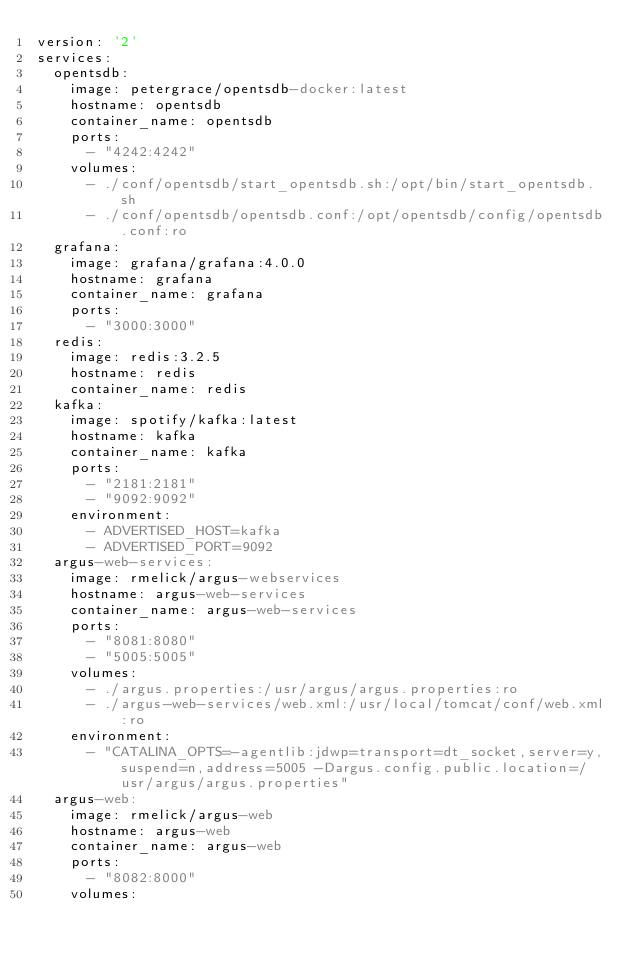<code> <loc_0><loc_0><loc_500><loc_500><_YAML_>version: '2'
services:
  opentsdb:
    image: petergrace/opentsdb-docker:latest
    hostname: opentsdb
    container_name: opentsdb
    ports:
      - "4242:4242"
    volumes:
      - ./conf/opentsdb/start_opentsdb.sh:/opt/bin/start_opentsdb.sh
      - ./conf/opentsdb/opentsdb.conf:/opt/opentsdb/config/opentsdb.conf:ro
  grafana:
    image: grafana/grafana:4.0.0
    hostname: grafana
    container_name: grafana
    ports:
      - "3000:3000"
  redis:
    image: redis:3.2.5
    hostname: redis
    container_name: redis
  kafka:
    image: spotify/kafka:latest
    hostname: kafka
    container_name: kafka
    ports:
      - "2181:2181"
      - "9092:9092"
    environment:
      - ADVERTISED_HOST=kafka
      - ADVERTISED_PORT=9092
  argus-web-services:
    image: rmelick/argus-webservices
    hostname: argus-web-services
    container_name: argus-web-services
    ports:
      - "8081:8080"
      - "5005:5005"
    volumes:
      - ./argus.properties:/usr/argus/argus.properties:ro
      - ./argus-web-services/web.xml:/usr/local/tomcat/conf/web.xml:ro
    environment:
      - "CATALINA_OPTS=-agentlib:jdwp=transport=dt_socket,server=y,suspend=n,address=5005 -Dargus.config.public.location=/usr/argus/argus.properties"
  argus-web:
    image: rmelick/argus-web
    hostname: argus-web
    container_name: argus-web
    ports:
      - "8082:8000"
    volumes:</code> 